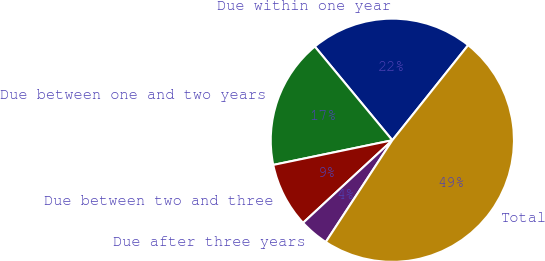Convert chart. <chart><loc_0><loc_0><loc_500><loc_500><pie_chart><fcel>Due within one year<fcel>Due between one and two years<fcel>Due between two and three<fcel>Due after three years<fcel>Total<nl><fcel>21.71%<fcel>17.25%<fcel>8.63%<fcel>3.9%<fcel>48.5%<nl></chart> 